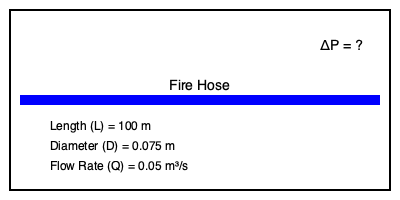Calculate the pressure drop (ΔP) in a fire hose with the following specifications:
- Length (L) = 100 meters
- Inner diameter (D) = 0.075 meters
- Flow rate (Q) = 0.05 m³/s
Assume the Darcy friction factor (f) is 0.02 and the density of water (ρ) is 1000 kg/m³. Use the Darcy-Weisbach equation to determine the pressure drop in pascals (Pa). To calculate the pressure drop in the fire hose, we'll use the Darcy-Weisbach equation:

$$\Delta P = f \cdot \frac{L}{D} \cdot \frac{\rho v^2}{2}$$

Where:
- $\Delta P$ is the pressure drop (Pa)
- $f$ is the Darcy friction factor (given as 0.02)
- $L$ is the length of the hose (100 m)
- $D$ is the inner diameter of the hose (0.075 m)
- $\rho$ is the density of water (1000 kg/m³)
- $v$ is the flow velocity (m/s)

Steps to solve:

1. Calculate the cross-sectional area of the hose:
   $$A = \frac{\pi D^2}{4} = \frac{\pi (0.075 \text{ m})^2}{4} = 4.418 \times 10^{-3} \text{ m}^2$$

2. Calculate the flow velocity using $Q = Av$:
   $$v = \frac{Q}{A} = \frac{0.05 \text{ m}^3/\text{s}}{4.418 \times 10^{-3} \text{ m}^2} = 11.32 \text{ m/s}$$

3. Substitute all values into the Darcy-Weisbach equation:
   $$\Delta P = 0.02 \cdot \frac{100 \text{ m}}{0.075 \text{ m}} \cdot \frac{1000 \text{ kg/m}^3 \cdot (11.32 \text{ m/s})^2}{2}$$

4. Calculate the result:
   $$\Delta P = 0.02 \cdot 1333.33 \cdot 64062.12 \text{ Pa} = 1,708,323 \text{ Pa}$$

5. Convert to kilopascals (kPa) for a more manageable unit:
   $$\Delta P = 1,708 \text{ kPa}$$
Answer: 1,708 kPa 